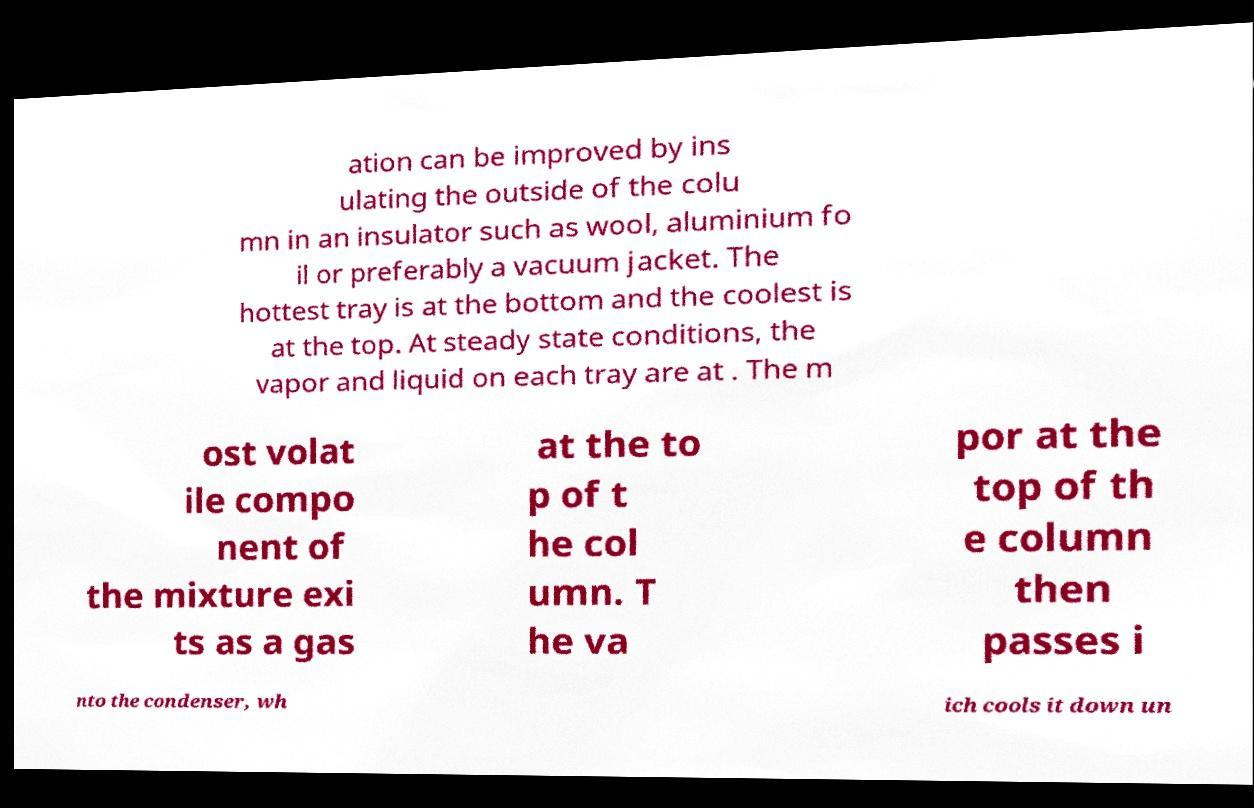Could you extract and type out the text from this image? ation can be improved by ins ulating the outside of the colu mn in an insulator such as wool, aluminium fo il or preferably a vacuum jacket. The hottest tray is at the bottom and the coolest is at the top. At steady state conditions, the vapor and liquid on each tray are at . The m ost volat ile compo nent of the mixture exi ts as a gas at the to p of t he col umn. T he va por at the top of th e column then passes i nto the condenser, wh ich cools it down un 